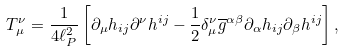<formula> <loc_0><loc_0><loc_500><loc_500>T _ { \mu } ^ { \nu } = \frac { 1 } { 4 \ell _ { P } ^ { 2 } } \left [ \partial _ { \mu } h _ { i j } \partial ^ { \nu } h ^ { i j } - \frac { 1 } { 2 } \delta _ { \mu } ^ { \nu } \overline { g } ^ { \alpha \beta } \partial _ { \alpha } h _ { i j } \partial _ { \beta } h ^ { i j } \right ] ,</formula> 